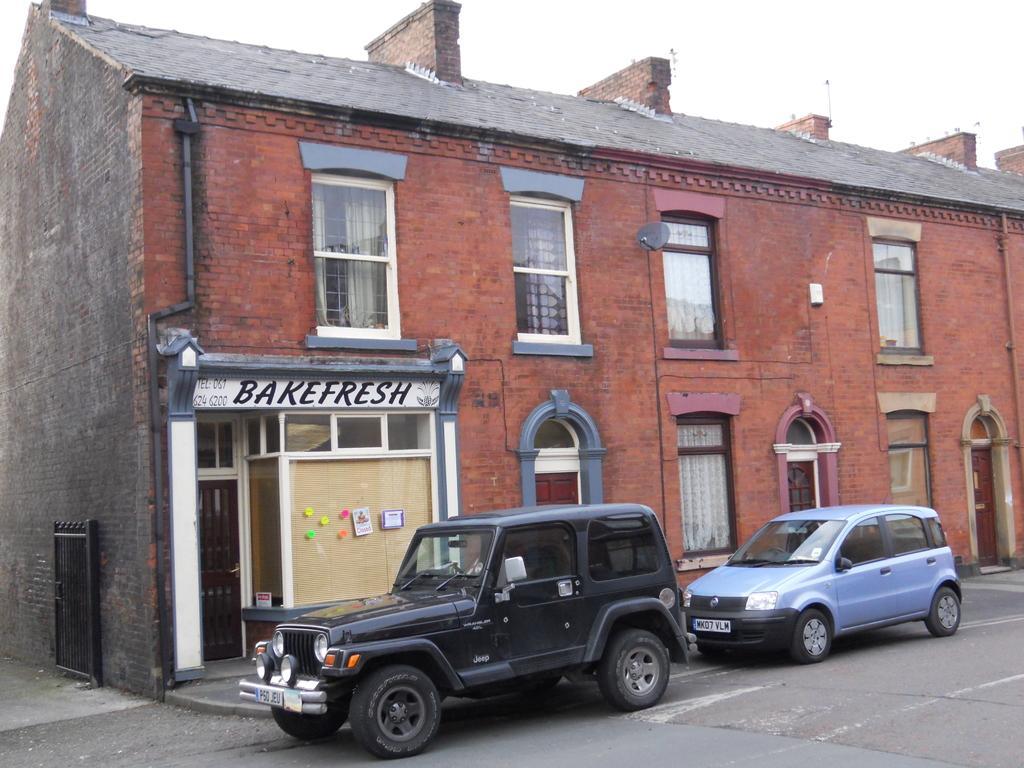Please provide a concise description of this image. In this image I can see at the bottom there are two vehicles on the road. On the left side it looks like a store, this is a building. At the top there is the sky. 